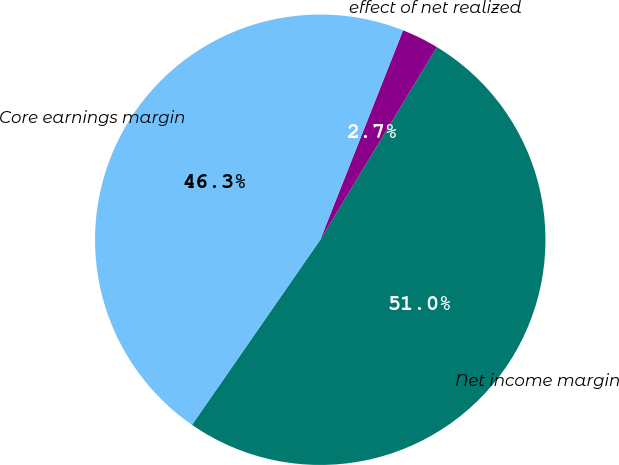Convert chart. <chart><loc_0><loc_0><loc_500><loc_500><pie_chart><fcel>Net income margin<fcel>effect of net realized<fcel>Core earnings margin<nl><fcel>50.98%<fcel>2.67%<fcel>46.35%<nl></chart> 